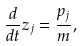<formula> <loc_0><loc_0><loc_500><loc_500>\frac { d } { d t } z _ { j } = \frac { p _ { j } } { m } ,</formula> 